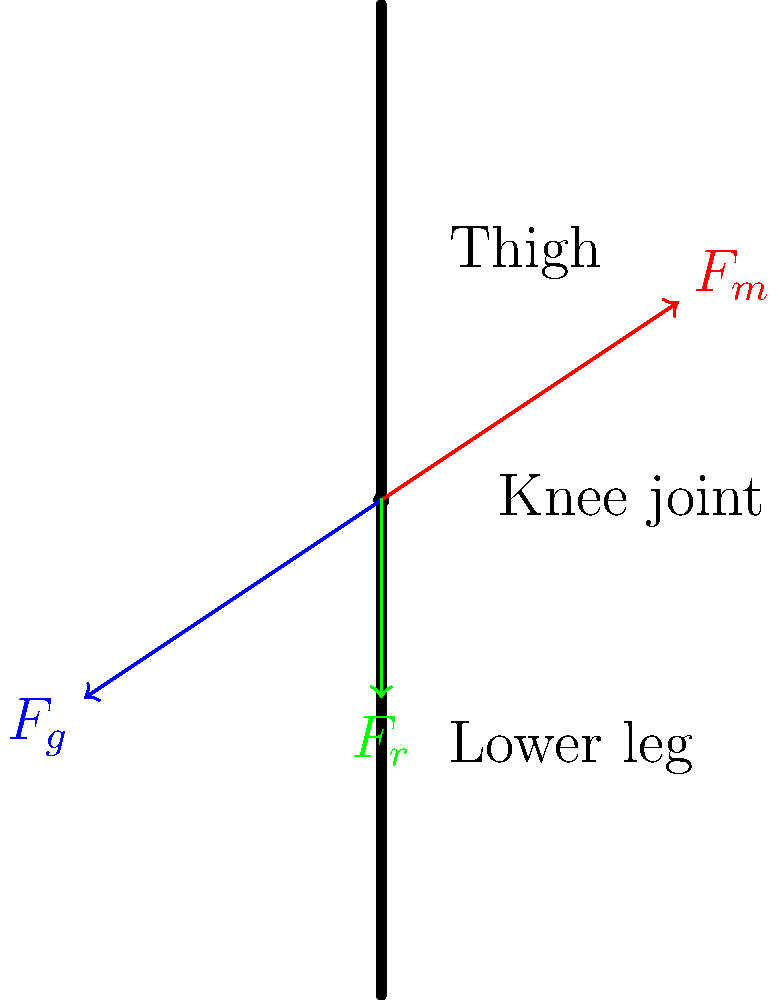As a project manager overseeing the implementation of a content management system for biomechanics research, you need to understand the forces acting on a human knee joint during walking. Based on the diagram, which force is most likely responsible for stabilizing the knee joint and preventing excessive anterior tibial translation? To answer this question, let's analyze the forces acting on the knee joint during walking:

1. $F_m$ (red arrow): This represents the muscle force, likely from the quadriceps, acting upward and forward on the tibia.

2. $F_g$ (blue arrow): This represents the ground reaction force, acting upward and backward on the tibia through the foot and ankle.

3. $F_r$ (green arrow): This represents a restraining force, acting downward on the tibia.

The knee joint needs to be stabilized to prevent excessive anterior (forward) movement of the tibia relative to the femur during walking. This movement is called anterior tibial translation.

The force most responsible for preventing this excessive movement is $F_r$, which is likely representing the action of the anterior cruciate ligament (ACL). The ACL connects the femur to the tibia and prevents the tibia from sliding too far forward relative to the femur.

While $F_m$ (muscle force) and $F_g$ (ground reaction force) play important roles in locomotion, they don't directly prevent anterior tibial translation. In fact, $F_m$ could potentially increase this translation if not counteracted.

Therefore, $F_r$ is the force most likely responsible for stabilizing the knee joint and preventing excessive anterior tibial translation during walking.
Answer: $F_r$ (restraining force, likely representing the ACL) 